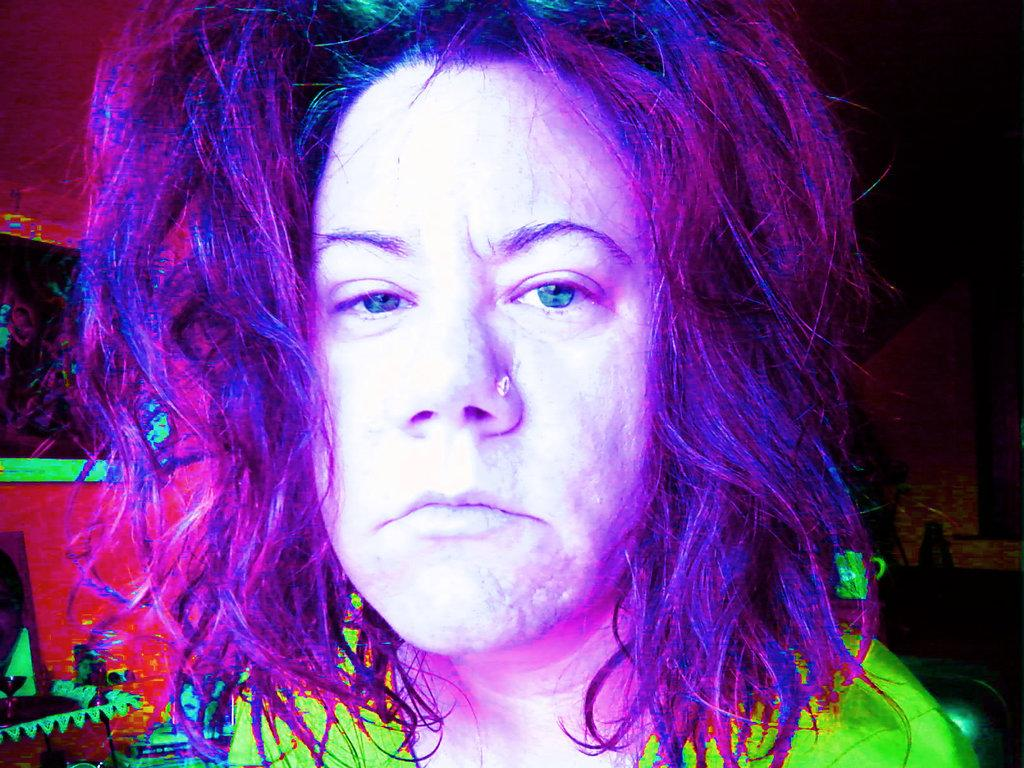Who is the main subject in the image? There is a woman in the image. What is a unique feature of the woman's appearance? The woman has purple hair. What is the woman wearing in the image? The woman is wearing a green dress. Where is the woman located in the image? The woman is in the middle of the image. What type of jar is the woman holding in the image? There is no jar present in the image; the woman is not holding anything. 